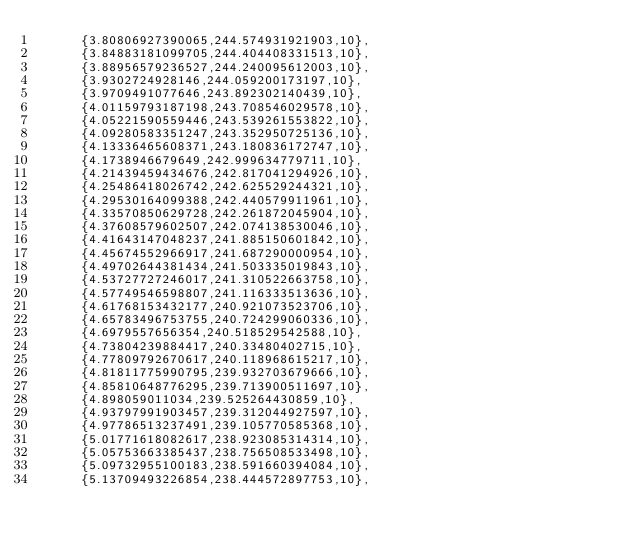<code> <loc_0><loc_0><loc_500><loc_500><_Java_>      {3.80806927390065,244.574931921903,10},
      {3.84883181099705,244.404408331513,10},
      {3.88956579236527,244.240095612003,10},
      {3.9302724928146,244.059200173197,10},
      {3.9709491077646,243.892302140439,10},
      {4.01159793187198,243.708546029578,10},
      {4.05221590559446,243.539261553822,10},
      {4.09280583351247,243.352950725136,10},
      {4.13336465608371,243.180836172747,10},
      {4.1738946679649,242.999634779711,10},
      {4.21439459434676,242.817041294926,10},
      {4.25486418026742,242.625529244321,10},
      {4.29530164099388,242.440579911961,10},
      {4.33570850629728,242.261872045904,10},
      {4.37608579602507,242.074138530046,10},
      {4.41643147048237,241.885150601842,10},
      {4.45674552966917,241.687290000954,10},
      {4.49702644381434,241.503335019843,10},
      {4.53727727246017,241.310522663758,10},
      {4.57749546598807,241.116333513636,10},
      {4.61768153432177,240.921073523706,10},
      {4.65783496753755,240.724299060336,10},
      {4.6979557656354,240.518529542588,10},
      {4.73804239884417,240.33480402715,10},
      {4.77809792670617,240.118968615217,10},
      {4.81811775990795,239.932703679666,10},
      {4.85810648776295,239.713900511697,10},
      {4.898059011034,239.525264430859,10},
      {4.93797991903457,239.312044927597,10},
      {4.97786513237491,239.105770585368,10},
      {5.01771618082617,238.923085314314,10},
      {5.05753663385437,238.756508533498,10},
      {5.09732955100183,238.591660394084,10},
      {5.13709493226854,238.444572897753,10},</code> 